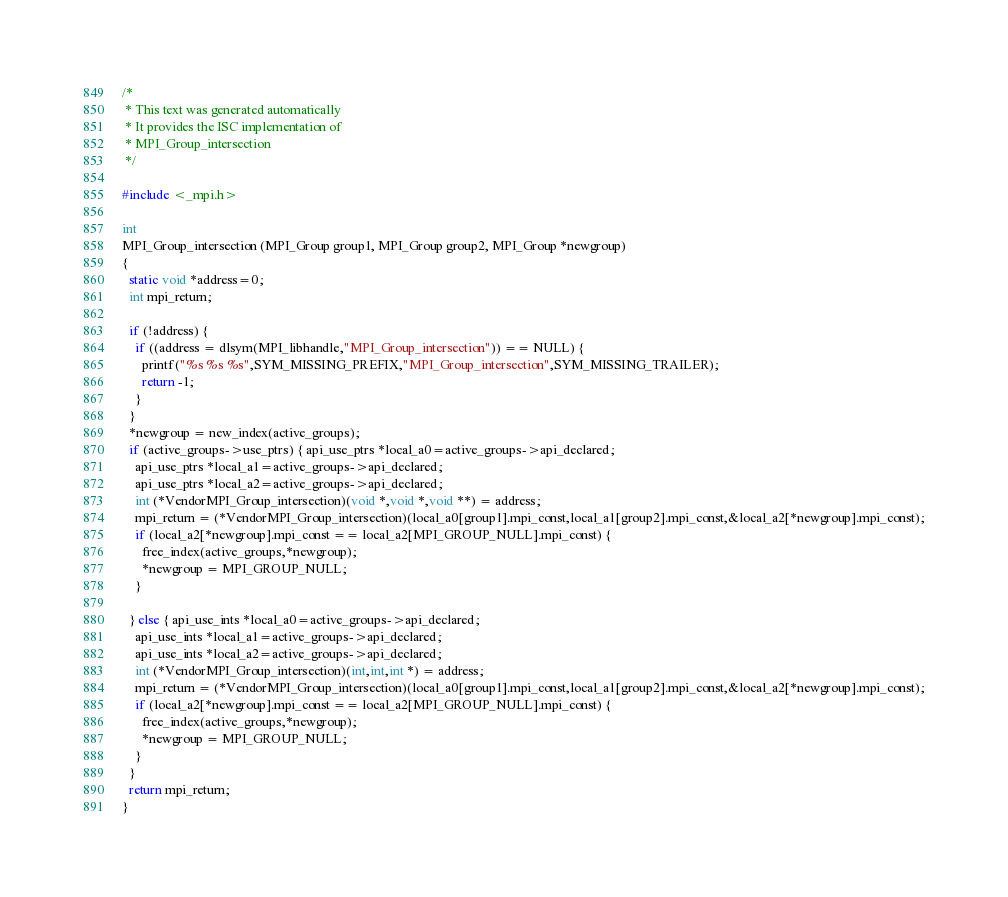Convert code to text. <code><loc_0><loc_0><loc_500><loc_500><_C_>
/*
 * This text was generated automatically
 * It provides the ISC implementation of
 * MPI_Group_intersection
 */

#include <_mpi.h>

int
MPI_Group_intersection (MPI_Group group1, MPI_Group group2, MPI_Group *newgroup)
{
  static void *address=0;
  int mpi_return;

  if (!address) {
    if ((address = dlsym(MPI_libhandle,"MPI_Group_intersection")) == NULL) {
      printf("%s %s %s",SYM_MISSING_PREFIX,"MPI_Group_intersection",SYM_MISSING_TRAILER);
      return -1;
    }
  }
  *newgroup = new_index(active_groups);
  if (active_groups->use_ptrs) { api_use_ptrs *local_a0=active_groups->api_declared;
    api_use_ptrs *local_a1=active_groups->api_declared;
    api_use_ptrs *local_a2=active_groups->api_declared;
    int (*VendorMPI_Group_intersection)(void *,void *,void **) = address;
    mpi_return = (*VendorMPI_Group_intersection)(local_a0[group1].mpi_const,local_a1[group2].mpi_const,&local_a2[*newgroup].mpi_const);
    if (local_a2[*newgroup].mpi_const == local_a2[MPI_GROUP_NULL].mpi_const) {
      free_index(active_groups,*newgroup);
      *newgroup = MPI_GROUP_NULL;
    }

  } else { api_use_ints *local_a0=active_groups->api_declared;
    api_use_ints *local_a1=active_groups->api_declared;
    api_use_ints *local_a2=active_groups->api_declared;
    int (*VendorMPI_Group_intersection)(int,int,int *) = address;
    mpi_return = (*VendorMPI_Group_intersection)(local_a0[group1].mpi_const,local_a1[group2].mpi_const,&local_a2[*newgroup].mpi_const);
    if (local_a2[*newgroup].mpi_const == local_a2[MPI_GROUP_NULL].mpi_const) {
      free_index(active_groups,*newgroup);
      *newgroup = MPI_GROUP_NULL;
    }
  }
  return mpi_return;
}
</code> 